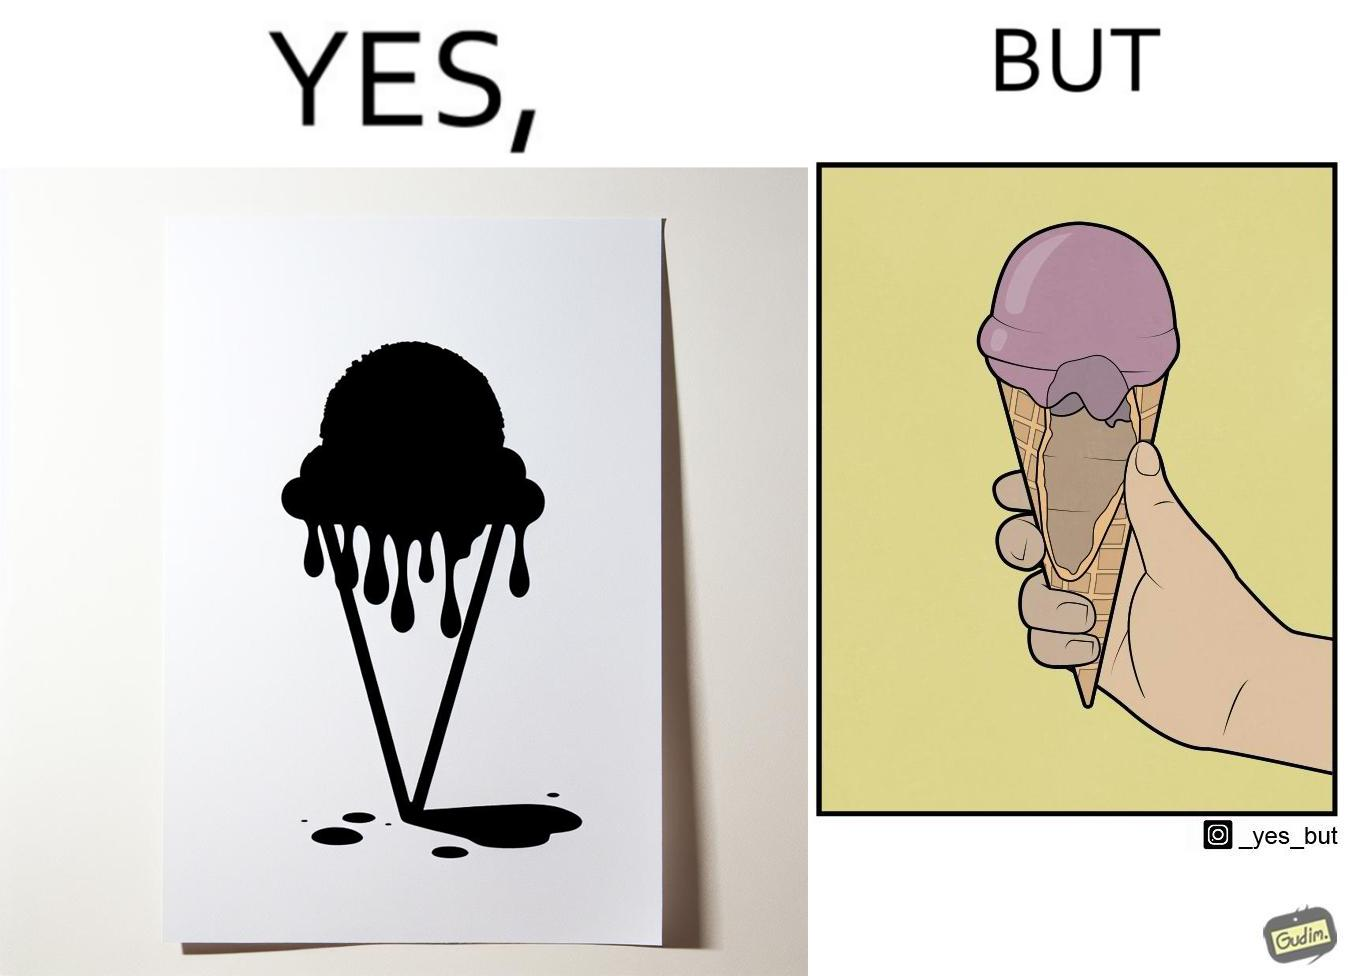What makes this image funny or satirical? The image is ironic, because in one image the softy cone is shown filled with softy but in second image it is visible that only the top of the cone is filled and at the inside the cone is vacant 